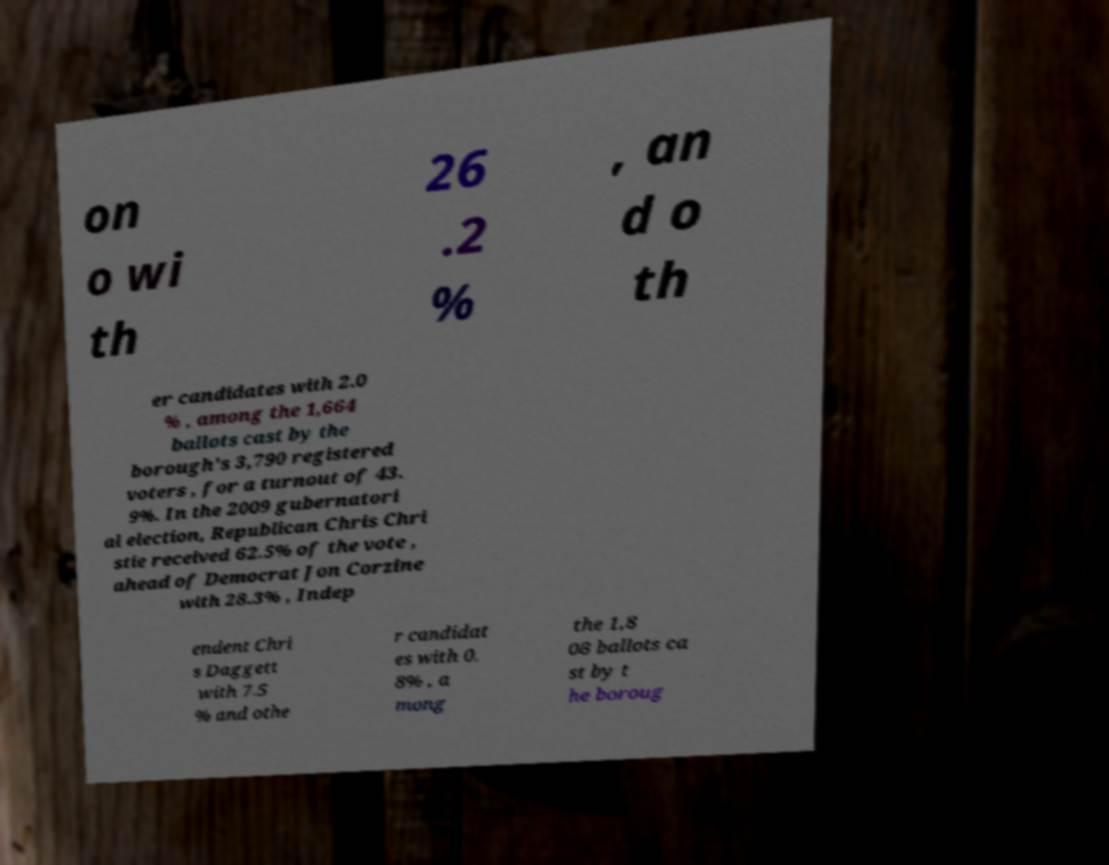Please read and relay the text visible in this image. What does it say? on o wi th 26 .2 % , an d o th er candidates with 2.0 % , among the 1,664 ballots cast by the borough's 3,790 registered voters , for a turnout of 43. 9%. In the 2009 gubernatori al election, Republican Chris Chri stie received 62.5% of the vote , ahead of Democrat Jon Corzine with 28.3% , Indep endent Chri s Daggett with 7.5 % and othe r candidat es with 0. 8% , a mong the 1,8 08 ballots ca st by t he boroug 